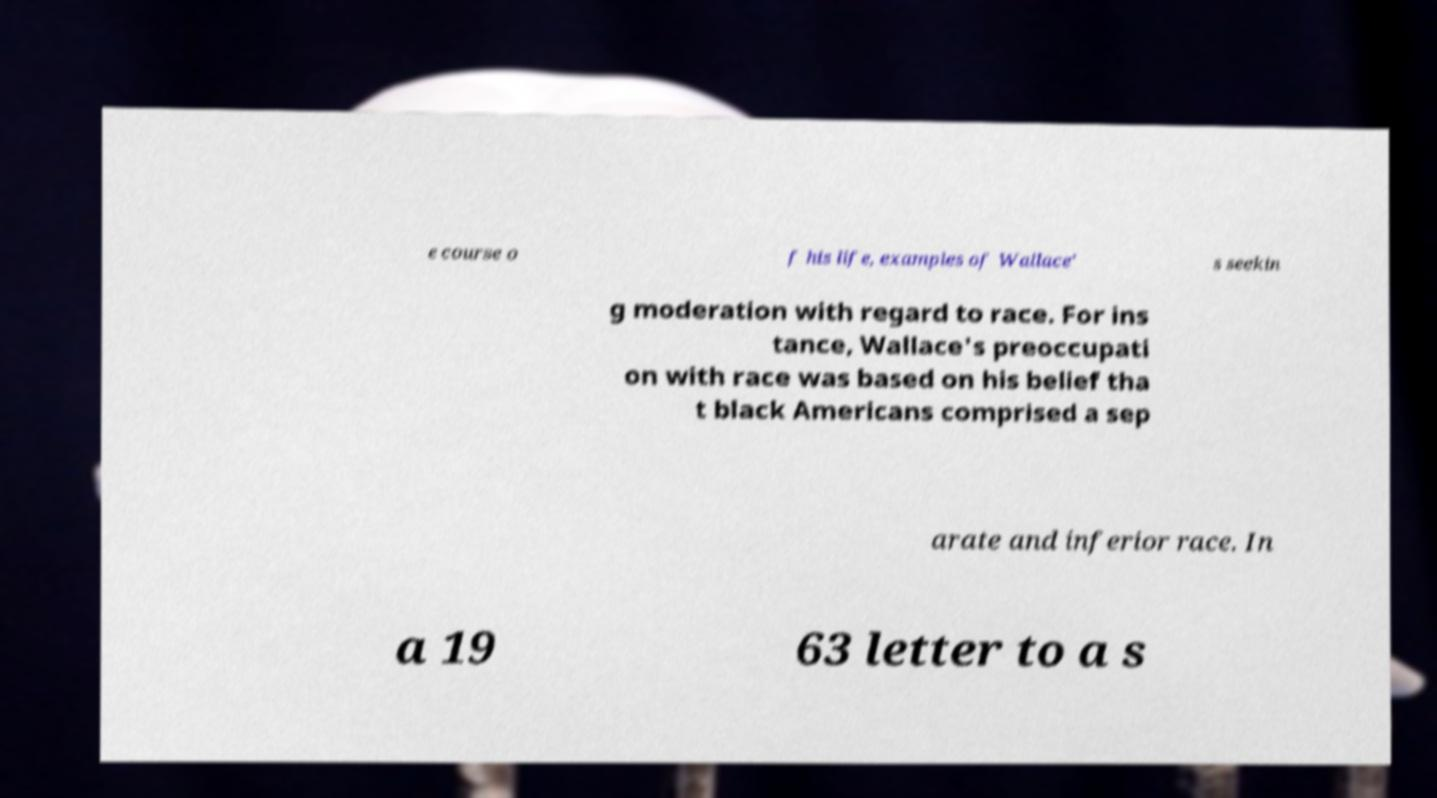There's text embedded in this image that I need extracted. Can you transcribe it verbatim? e course o f his life, examples of Wallace' s seekin g moderation with regard to race. For ins tance, Wallace's preoccupati on with race was based on his belief tha t black Americans comprised a sep arate and inferior race. In a 19 63 letter to a s 